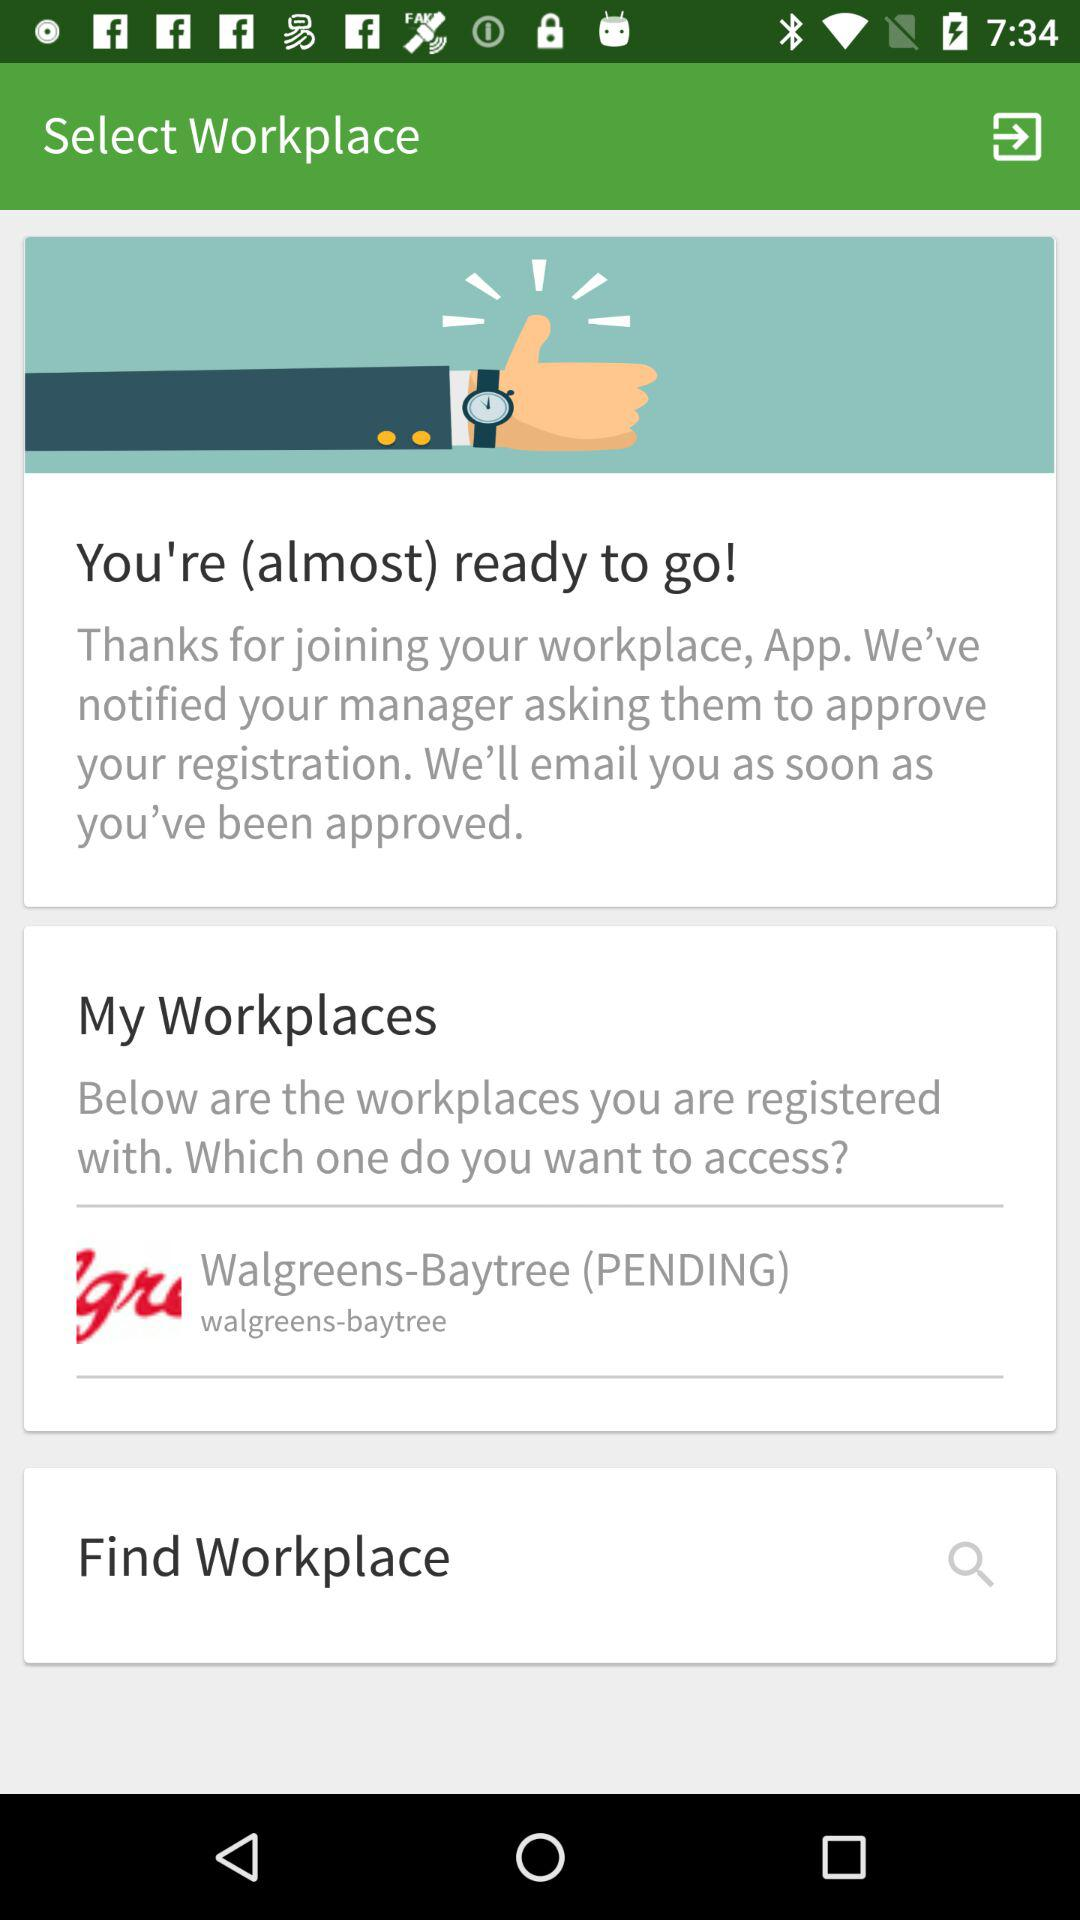Where is my workplace located?
When the provided information is insufficient, respond with <no answer>. <no answer> 